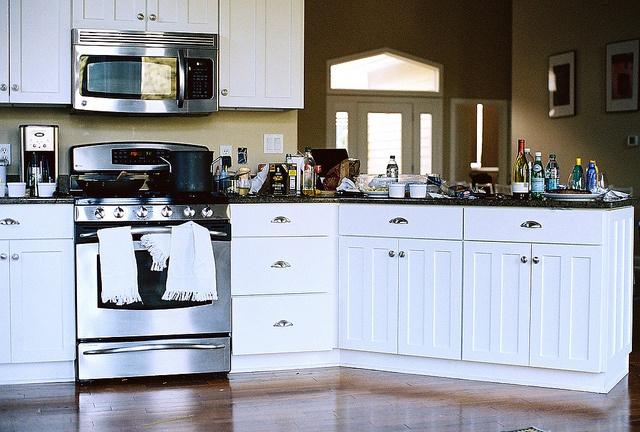Describe the objects in this image and their specific colors. I can see oven in darkgray, lavender, and black tones, microwave in darkgray, black, white, and gray tones, bottle in darkgray, black, lavender, olive, and maroon tones, bottle in darkgray, black, gray, and lightgray tones, and bottle in darkgray, black, lightblue, lightgray, and gray tones in this image. 